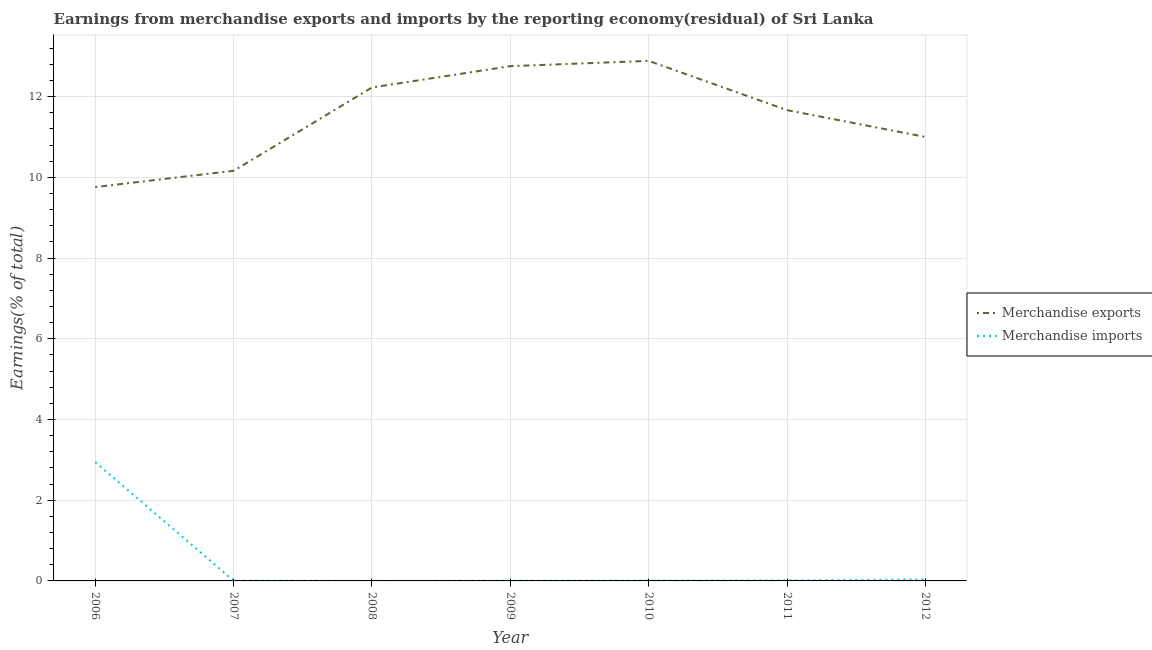How many different coloured lines are there?
Make the answer very short. 2. Does the line corresponding to earnings from merchandise imports intersect with the line corresponding to earnings from merchandise exports?
Ensure brevity in your answer.  No. What is the earnings from merchandise imports in 2010?
Your answer should be very brief. 0.01. Across all years, what is the maximum earnings from merchandise exports?
Your response must be concise. 12.89. Across all years, what is the minimum earnings from merchandise exports?
Your answer should be compact. 9.76. In which year was the earnings from merchandise exports maximum?
Your answer should be very brief. 2010. In which year was the earnings from merchandise exports minimum?
Your answer should be compact. 2006. What is the total earnings from merchandise exports in the graph?
Keep it short and to the point. 80.46. What is the difference between the earnings from merchandise imports in 2007 and that in 2012?
Give a very brief answer. -0.03. What is the difference between the earnings from merchandise imports in 2007 and the earnings from merchandise exports in 2006?
Offer a terse response. -9.75. What is the average earnings from merchandise exports per year?
Keep it short and to the point. 11.49. In the year 2010, what is the difference between the earnings from merchandise exports and earnings from merchandise imports?
Offer a very short reply. 12.88. What is the ratio of the earnings from merchandise exports in 2006 to that in 2008?
Your response must be concise. 0.8. What is the difference between the highest and the second highest earnings from merchandise exports?
Your response must be concise. 0.13. What is the difference between the highest and the lowest earnings from merchandise imports?
Offer a terse response. 2.94. Is the earnings from merchandise exports strictly less than the earnings from merchandise imports over the years?
Your answer should be very brief. No. How many lines are there?
Offer a very short reply. 2. Does the graph contain any zero values?
Provide a short and direct response. No. How many legend labels are there?
Make the answer very short. 2. What is the title of the graph?
Offer a terse response. Earnings from merchandise exports and imports by the reporting economy(residual) of Sri Lanka. Does "Long-term debt" appear as one of the legend labels in the graph?
Ensure brevity in your answer.  No. What is the label or title of the X-axis?
Offer a very short reply. Year. What is the label or title of the Y-axis?
Offer a very short reply. Earnings(% of total). What is the Earnings(% of total) of Merchandise exports in 2006?
Give a very brief answer. 9.76. What is the Earnings(% of total) in Merchandise imports in 2006?
Provide a short and direct response. 2.94. What is the Earnings(% of total) in Merchandise exports in 2007?
Provide a succinct answer. 10.16. What is the Earnings(% of total) in Merchandise imports in 2007?
Ensure brevity in your answer.  0.01. What is the Earnings(% of total) in Merchandise exports in 2008?
Keep it short and to the point. 12.23. What is the Earnings(% of total) of Merchandise imports in 2008?
Offer a terse response. 0. What is the Earnings(% of total) of Merchandise exports in 2009?
Your answer should be compact. 12.76. What is the Earnings(% of total) of Merchandise imports in 2009?
Ensure brevity in your answer.  0. What is the Earnings(% of total) in Merchandise exports in 2010?
Give a very brief answer. 12.89. What is the Earnings(% of total) of Merchandise imports in 2010?
Provide a succinct answer. 0.01. What is the Earnings(% of total) of Merchandise exports in 2011?
Offer a very short reply. 11.67. What is the Earnings(% of total) of Merchandise imports in 2011?
Offer a very short reply. 0.01. What is the Earnings(% of total) of Merchandise exports in 2012?
Make the answer very short. 11. What is the Earnings(% of total) of Merchandise imports in 2012?
Your response must be concise. 0.03. Across all years, what is the maximum Earnings(% of total) in Merchandise exports?
Provide a succinct answer. 12.89. Across all years, what is the maximum Earnings(% of total) in Merchandise imports?
Keep it short and to the point. 2.94. Across all years, what is the minimum Earnings(% of total) of Merchandise exports?
Your answer should be very brief. 9.76. Across all years, what is the minimum Earnings(% of total) of Merchandise imports?
Provide a short and direct response. 0. What is the total Earnings(% of total) of Merchandise exports in the graph?
Ensure brevity in your answer.  80.46. What is the total Earnings(% of total) of Merchandise imports in the graph?
Offer a very short reply. 3.01. What is the difference between the Earnings(% of total) of Merchandise exports in 2006 and that in 2007?
Your response must be concise. -0.4. What is the difference between the Earnings(% of total) in Merchandise imports in 2006 and that in 2007?
Offer a very short reply. 2.94. What is the difference between the Earnings(% of total) in Merchandise exports in 2006 and that in 2008?
Your answer should be compact. -2.47. What is the difference between the Earnings(% of total) of Merchandise imports in 2006 and that in 2008?
Provide a succinct answer. 2.94. What is the difference between the Earnings(% of total) of Merchandise exports in 2006 and that in 2009?
Provide a succinct answer. -3. What is the difference between the Earnings(% of total) of Merchandise imports in 2006 and that in 2009?
Ensure brevity in your answer.  2.94. What is the difference between the Earnings(% of total) of Merchandise exports in 2006 and that in 2010?
Provide a short and direct response. -3.13. What is the difference between the Earnings(% of total) in Merchandise imports in 2006 and that in 2010?
Offer a terse response. 2.94. What is the difference between the Earnings(% of total) in Merchandise exports in 2006 and that in 2011?
Give a very brief answer. -1.91. What is the difference between the Earnings(% of total) in Merchandise imports in 2006 and that in 2011?
Make the answer very short. 2.93. What is the difference between the Earnings(% of total) in Merchandise exports in 2006 and that in 2012?
Provide a succinct answer. -1.24. What is the difference between the Earnings(% of total) in Merchandise imports in 2006 and that in 2012?
Provide a succinct answer. 2.91. What is the difference between the Earnings(% of total) of Merchandise exports in 2007 and that in 2008?
Offer a terse response. -2.06. What is the difference between the Earnings(% of total) in Merchandise imports in 2007 and that in 2008?
Your answer should be very brief. 0. What is the difference between the Earnings(% of total) in Merchandise exports in 2007 and that in 2009?
Provide a succinct answer. -2.59. What is the difference between the Earnings(% of total) in Merchandise imports in 2007 and that in 2009?
Your answer should be very brief. 0. What is the difference between the Earnings(% of total) in Merchandise exports in 2007 and that in 2010?
Make the answer very short. -2.72. What is the difference between the Earnings(% of total) of Merchandise imports in 2007 and that in 2010?
Your response must be concise. -0. What is the difference between the Earnings(% of total) in Merchandise exports in 2007 and that in 2011?
Keep it short and to the point. -1.5. What is the difference between the Earnings(% of total) in Merchandise imports in 2007 and that in 2011?
Ensure brevity in your answer.  -0.01. What is the difference between the Earnings(% of total) of Merchandise exports in 2007 and that in 2012?
Ensure brevity in your answer.  -0.84. What is the difference between the Earnings(% of total) of Merchandise imports in 2007 and that in 2012?
Provide a short and direct response. -0.03. What is the difference between the Earnings(% of total) of Merchandise exports in 2008 and that in 2009?
Make the answer very short. -0.53. What is the difference between the Earnings(% of total) in Merchandise imports in 2008 and that in 2009?
Offer a terse response. -0. What is the difference between the Earnings(% of total) in Merchandise exports in 2008 and that in 2010?
Provide a succinct answer. -0.66. What is the difference between the Earnings(% of total) in Merchandise imports in 2008 and that in 2010?
Offer a very short reply. -0.01. What is the difference between the Earnings(% of total) of Merchandise exports in 2008 and that in 2011?
Make the answer very short. 0.56. What is the difference between the Earnings(% of total) in Merchandise imports in 2008 and that in 2011?
Make the answer very short. -0.01. What is the difference between the Earnings(% of total) in Merchandise exports in 2008 and that in 2012?
Ensure brevity in your answer.  1.23. What is the difference between the Earnings(% of total) in Merchandise imports in 2008 and that in 2012?
Your answer should be compact. -0.03. What is the difference between the Earnings(% of total) of Merchandise exports in 2009 and that in 2010?
Give a very brief answer. -0.13. What is the difference between the Earnings(% of total) in Merchandise imports in 2009 and that in 2010?
Your answer should be very brief. -0. What is the difference between the Earnings(% of total) of Merchandise exports in 2009 and that in 2011?
Offer a terse response. 1.09. What is the difference between the Earnings(% of total) of Merchandise imports in 2009 and that in 2011?
Your response must be concise. -0.01. What is the difference between the Earnings(% of total) of Merchandise exports in 2009 and that in 2012?
Keep it short and to the point. 1.75. What is the difference between the Earnings(% of total) in Merchandise imports in 2009 and that in 2012?
Offer a very short reply. -0.03. What is the difference between the Earnings(% of total) in Merchandise exports in 2010 and that in 2011?
Offer a terse response. 1.22. What is the difference between the Earnings(% of total) in Merchandise imports in 2010 and that in 2011?
Keep it short and to the point. -0.01. What is the difference between the Earnings(% of total) in Merchandise exports in 2010 and that in 2012?
Ensure brevity in your answer.  1.89. What is the difference between the Earnings(% of total) in Merchandise imports in 2010 and that in 2012?
Offer a very short reply. -0.03. What is the difference between the Earnings(% of total) of Merchandise exports in 2011 and that in 2012?
Give a very brief answer. 0.66. What is the difference between the Earnings(% of total) of Merchandise imports in 2011 and that in 2012?
Your response must be concise. -0.02. What is the difference between the Earnings(% of total) in Merchandise exports in 2006 and the Earnings(% of total) in Merchandise imports in 2007?
Your answer should be very brief. 9.75. What is the difference between the Earnings(% of total) in Merchandise exports in 2006 and the Earnings(% of total) in Merchandise imports in 2008?
Ensure brevity in your answer.  9.76. What is the difference between the Earnings(% of total) in Merchandise exports in 2006 and the Earnings(% of total) in Merchandise imports in 2009?
Offer a very short reply. 9.76. What is the difference between the Earnings(% of total) in Merchandise exports in 2006 and the Earnings(% of total) in Merchandise imports in 2010?
Your response must be concise. 9.75. What is the difference between the Earnings(% of total) of Merchandise exports in 2006 and the Earnings(% of total) of Merchandise imports in 2011?
Your response must be concise. 9.75. What is the difference between the Earnings(% of total) in Merchandise exports in 2006 and the Earnings(% of total) in Merchandise imports in 2012?
Your response must be concise. 9.73. What is the difference between the Earnings(% of total) of Merchandise exports in 2007 and the Earnings(% of total) of Merchandise imports in 2008?
Keep it short and to the point. 10.16. What is the difference between the Earnings(% of total) of Merchandise exports in 2007 and the Earnings(% of total) of Merchandise imports in 2009?
Keep it short and to the point. 10.16. What is the difference between the Earnings(% of total) in Merchandise exports in 2007 and the Earnings(% of total) in Merchandise imports in 2010?
Your answer should be compact. 10.16. What is the difference between the Earnings(% of total) of Merchandise exports in 2007 and the Earnings(% of total) of Merchandise imports in 2011?
Provide a short and direct response. 10.15. What is the difference between the Earnings(% of total) of Merchandise exports in 2007 and the Earnings(% of total) of Merchandise imports in 2012?
Provide a succinct answer. 10.13. What is the difference between the Earnings(% of total) in Merchandise exports in 2008 and the Earnings(% of total) in Merchandise imports in 2009?
Your response must be concise. 12.22. What is the difference between the Earnings(% of total) of Merchandise exports in 2008 and the Earnings(% of total) of Merchandise imports in 2010?
Your answer should be compact. 12.22. What is the difference between the Earnings(% of total) in Merchandise exports in 2008 and the Earnings(% of total) in Merchandise imports in 2011?
Your response must be concise. 12.21. What is the difference between the Earnings(% of total) of Merchandise exports in 2008 and the Earnings(% of total) of Merchandise imports in 2012?
Provide a succinct answer. 12.19. What is the difference between the Earnings(% of total) in Merchandise exports in 2009 and the Earnings(% of total) in Merchandise imports in 2010?
Your answer should be compact. 12.75. What is the difference between the Earnings(% of total) in Merchandise exports in 2009 and the Earnings(% of total) in Merchandise imports in 2011?
Keep it short and to the point. 12.74. What is the difference between the Earnings(% of total) in Merchandise exports in 2009 and the Earnings(% of total) in Merchandise imports in 2012?
Ensure brevity in your answer.  12.72. What is the difference between the Earnings(% of total) of Merchandise exports in 2010 and the Earnings(% of total) of Merchandise imports in 2011?
Keep it short and to the point. 12.87. What is the difference between the Earnings(% of total) in Merchandise exports in 2010 and the Earnings(% of total) in Merchandise imports in 2012?
Offer a very short reply. 12.85. What is the difference between the Earnings(% of total) of Merchandise exports in 2011 and the Earnings(% of total) of Merchandise imports in 2012?
Give a very brief answer. 11.63. What is the average Earnings(% of total) in Merchandise exports per year?
Your answer should be compact. 11.49. What is the average Earnings(% of total) in Merchandise imports per year?
Provide a succinct answer. 0.43. In the year 2006, what is the difference between the Earnings(% of total) of Merchandise exports and Earnings(% of total) of Merchandise imports?
Keep it short and to the point. 6.82. In the year 2007, what is the difference between the Earnings(% of total) of Merchandise exports and Earnings(% of total) of Merchandise imports?
Your answer should be compact. 10.16. In the year 2008, what is the difference between the Earnings(% of total) in Merchandise exports and Earnings(% of total) in Merchandise imports?
Offer a very short reply. 12.23. In the year 2009, what is the difference between the Earnings(% of total) of Merchandise exports and Earnings(% of total) of Merchandise imports?
Give a very brief answer. 12.75. In the year 2010, what is the difference between the Earnings(% of total) of Merchandise exports and Earnings(% of total) of Merchandise imports?
Keep it short and to the point. 12.88. In the year 2011, what is the difference between the Earnings(% of total) of Merchandise exports and Earnings(% of total) of Merchandise imports?
Keep it short and to the point. 11.65. In the year 2012, what is the difference between the Earnings(% of total) of Merchandise exports and Earnings(% of total) of Merchandise imports?
Make the answer very short. 10.97. What is the ratio of the Earnings(% of total) of Merchandise exports in 2006 to that in 2007?
Your response must be concise. 0.96. What is the ratio of the Earnings(% of total) of Merchandise imports in 2006 to that in 2007?
Ensure brevity in your answer.  502.52. What is the ratio of the Earnings(% of total) in Merchandise exports in 2006 to that in 2008?
Offer a very short reply. 0.8. What is the ratio of the Earnings(% of total) of Merchandise imports in 2006 to that in 2008?
Give a very brief answer. 2894.83. What is the ratio of the Earnings(% of total) in Merchandise exports in 2006 to that in 2009?
Offer a terse response. 0.77. What is the ratio of the Earnings(% of total) of Merchandise imports in 2006 to that in 2009?
Ensure brevity in your answer.  713.76. What is the ratio of the Earnings(% of total) of Merchandise exports in 2006 to that in 2010?
Your answer should be compact. 0.76. What is the ratio of the Earnings(% of total) of Merchandise imports in 2006 to that in 2010?
Make the answer very short. 425.91. What is the ratio of the Earnings(% of total) in Merchandise exports in 2006 to that in 2011?
Ensure brevity in your answer.  0.84. What is the ratio of the Earnings(% of total) of Merchandise imports in 2006 to that in 2011?
Offer a terse response. 226.61. What is the ratio of the Earnings(% of total) in Merchandise exports in 2006 to that in 2012?
Your response must be concise. 0.89. What is the ratio of the Earnings(% of total) of Merchandise imports in 2006 to that in 2012?
Give a very brief answer. 84.89. What is the ratio of the Earnings(% of total) of Merchandise exports in 2007 to that in 2008?
Make the answer very short. 0.83. What is the ratio of the Earnings(% of total) of Merchandise imports in 2007 to that in 2008?
Offer a very short reply. 5.76. What is the ratio of the Earnings(% of total) of Merchandise exports in 2007 to that in 2009?
Offer a terse response. 0.8. What is the ratio of the Earnings(% of total) in Merchandise imports in 2007 to that in 2009?
Ensure brevity in your answer.  1.42. What is the ratio of the Earnings(% of total) of Merchandise exports in 2007 to that in 2010?
Keep it short and to the point. 0.79. What is the ratio of the Earnings(% of total) of Merchandise imports in 2007 to that in 2010?
Your answer should be compact. 0.85. What is the ratio of the Earnings(% of total) of Merchandise exports in 2007 to that in 2011?
Provide a short and direct response. 0.87. What is the ratio of the Earnings(% of total) in Merchandise imports in 2007 to that in 2011?
Your answer should be very brief. 0.45. What is the ratio of the Earnings(% of total) in Merchandise exports in 2007 to that in 2012?
Provide a short and direct response. 0.92. What is the ratio of the Earnings(% of total) of Merchandise imports in 2007 to that in 2012?
Provide a short and direct response. 0.17. What is the ratio of the Earnings(% of total) of Merchandise exports in 2008 to that in 2009?
Give a very brief answer. 0.96. What is the ratio of the Earnings(% of total) in Merchandise imports in 2008 to that in 2009?
Keep it short and to the point. 0.25. What is the ratio of the Earnings(% of total) of Merchandise exports in 2008 to that in 2010?
Keep it short and to the point. 0.95. What is the ratio of the Earnings(% of total) in Merchandise imports in 2008 to that in 2010?
Your answer should be compact. 0.15. What is the ratio of the Earnings(% of total) of Merchandise exports in 2008 to that in 2011?
Ensure brevity in your answer.  1.05. What is the ratio of the Earnings(% of total) of Merchandise imports in 2008 to that in 2011?
Keep it short and to the point. 0.08. What is the ratio of the Earnings(% of total) in Merchandise exports in 2008 to that in 2012?
Give a very brief answer. 1.11. What is the ratio of the Earnings(% of total) of Merchandise imports in 2008 to that in 2012?
Your answer should be compact. 0.03. What is the ratio of the Earnings(% of total) in Merchandise exports in 2009 to that in 2010?
Your answer should be compact. 0.99. What is the ratio of the Earnings(% of total) in Merchandise imports in 2009 to that in 2010?
Keep it short and to the point. 0.6. What is the ratio of the Earnings(% of total) of Merchandise exports in 2009 to that in 2011?
Provide a succinct answer. 1.09. What is the ratio of the Earnings(% of total) of Merchandise imports in 2009 to that in 2011?
Your answer should be very brief. 0.32. What is the ratio of the Earnings(% of total) in Merchandise exports in 2009 to that in 2012?
Offer a terse response. 1.16. What is the ratio of the Earnings(% of total) in Merchandise imports in 2009 to that in 2012?
Offer a terse response. 0.12. What is the ratio of the Earnings(% of total) in Merchandise exports in 2010 to that in 2011?
Offer a terse response. 1.1. What is the ratio of the Earnings(% of total) in Merchandise imports in 2010 to that in 2011?
Your response must be concise. 0.53. What is the ratio of the Earnings(% of total) of Merchandise exports in 2010 to that in 2012?
Make the answer very short. 1.17. What is the ratio of the Earnings(% of total) of Merchandise imports in 2010 to that in 2012?
Give a very brief answer. 0.2. What is the ratio of the Earnings(% of total) of Merchandise exports in 2011 to that in 2012?
Provide a succinct answer. 1.06. What is the ratio of the Earnings(% of total) of Merchandise imports in 2011 to that in 2012?
Your response must be concise. 0.37. What is the difference between the highest and the second highest Earnings(% of total) in Merchandise exports?
Provide a short and direct response. 0.13. What is the difference between the highest and the second highest Earnings(% of total) in Merchandise imports?
Provide a short and direct response. 2.91. What is the difference between the highest and the lowest Earnings(% of total) of Merchandise exports?
Your answer should be compact. 3.13. What is the difference between the highest and the lowest Earnings(% of total) of Merchandise imports?
Your answer should be compact. 2.94. 